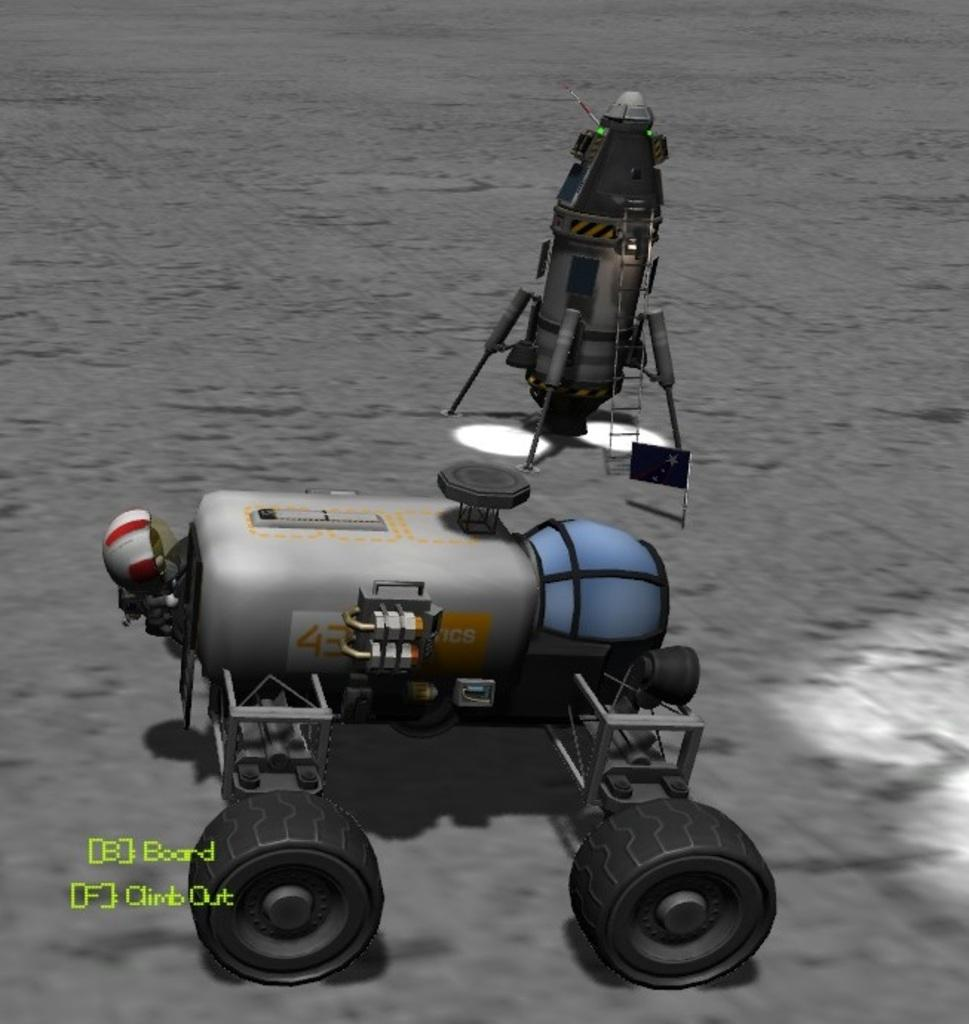<image>
Render a clear and concise summary of the photo. Rover device on a surface with the words Board and Climb Out below it. 